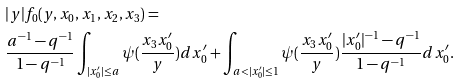<formula> <loc_0><loc_0><loc_500><loc_500>& | y | f _ { 0 } ( y , x _ { 0 } , x _ { 1 } , x _ { 2 } , x _ { 3 } ) = \\ & \frac { a ^ { - 1 } - q ^ { - 1 } } { 1 - q ^ { - 1 } } \int _ { | x ^ { \prime } _ { 0 } | \leq a } \psi ( \frac { x _ { 3 } x ^ { \prime } _ { 0 } } { y } ) d x ^ { \prime } _ { 0 } + \int _ { a < | x ^ { \prime } _ { 0 } | \leq 1 } \psi ( \frac { x _ { 3 } x ^ { \prime } _ { 0 } } { y } ) \frac { | x ^ { \prime } _ { 0 } | ^ { - 1 } - q ^ { - 1 } } { 1 - q ^ { - 1 } } d x ^ { \prime } _ { 0 } .</formula> 